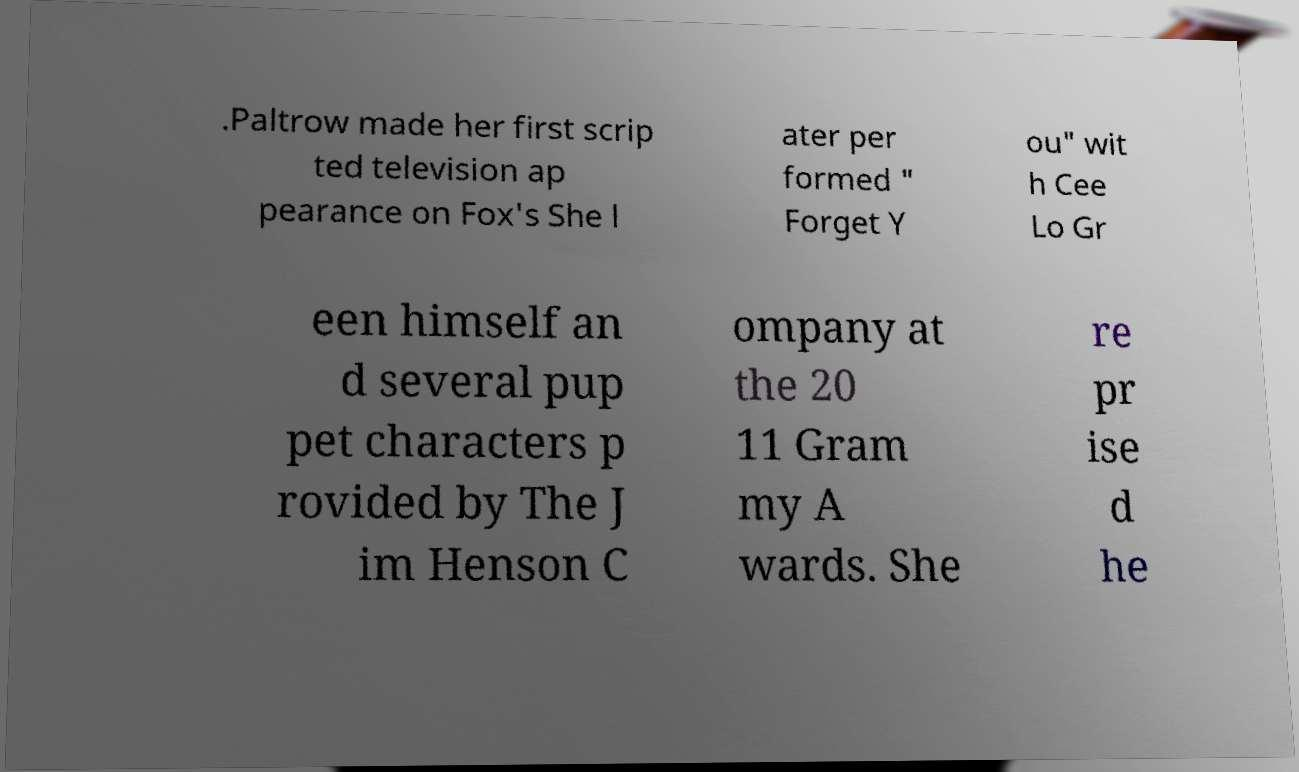Could you assist in decoding the text presented in this image and type it out clearly? .Paltrow made her first scrip ted television ap pearance on Fox's She l ater per formed " Forget Y ou" wit h Cee Lo Gr een himself an d several pup pet characters p rovided by The J im Henson C ompany at the 20 11 Gram my A wards. She re pr ise d he 